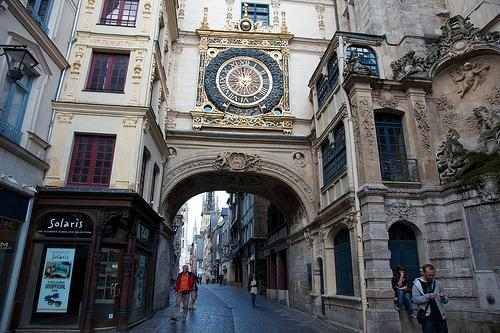What can be seen through the archway in the image? Buildings can be seen through the archway in the image. Mention one prominent architectural feature observed in the image. There is an elaborate archway in the image leading under a building. Write a sentence about the color and design of the pictured window. The window in the image features a red painted frame and has multiple panes of glass with an ornate design. Mention something unique about the clock in the image. The clock has an elaborate gold frame surrounding its black clock face with gold roman numerals. Provide a brief summary of the main objects that can be identified in the picture. The image features an ornate gold clock, a man in an orange shirt walking under an arch, a woman wearing jeans, a man with a black bag, and an advertisement for Solaris. What is the most distinctive piece of clothing in the image? The most distinctive piece of clothing in the image is the orange shirt being worn by a man walking under an arch. 